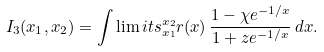Convert formula to latex. <formula><loc_0><loc_0><loc_500><loc_500>I _ { 3 } ( x _ { 1 } , x _ { 2 } ) = \int \lim i t s _ { x _ { 1 } } ^ { x _ { 2 } } r ( x ) \, \frac { 1 - \chi e ^ { - 1 / x } } { 1 + z e ^ { - 1 / x } } \, d x .</formula> 